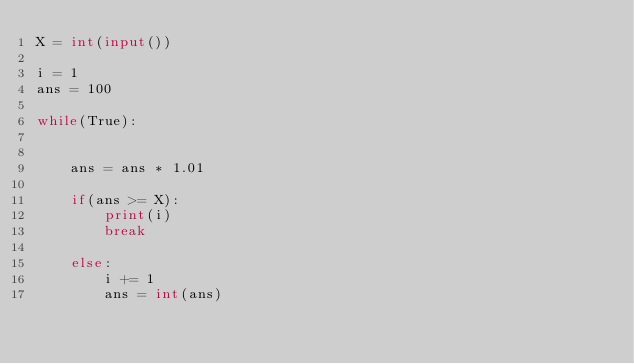<code> <loc_0><loc_0><loc_500><loc_500><_Python_>X = int(input())

i = 1
ans = 100

while(True):


    ans = ans * 1.01
    
    if(ans >= X):
        print(i)
        break

    else:
        i += 1
        ans = int(ans)</code> 